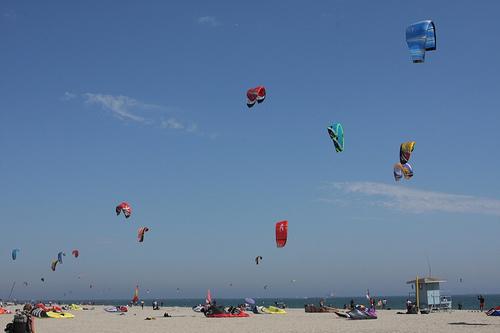How many kites are there?
Be succinct. 4. Is this a clear sky?
Answer briefly. Yes. What is flying in the sky?
Short answer required. Kites. How many kites are in the air?
Keep it brief. 20. Which direction is the wind blowing?
Concise answer only. Right. 